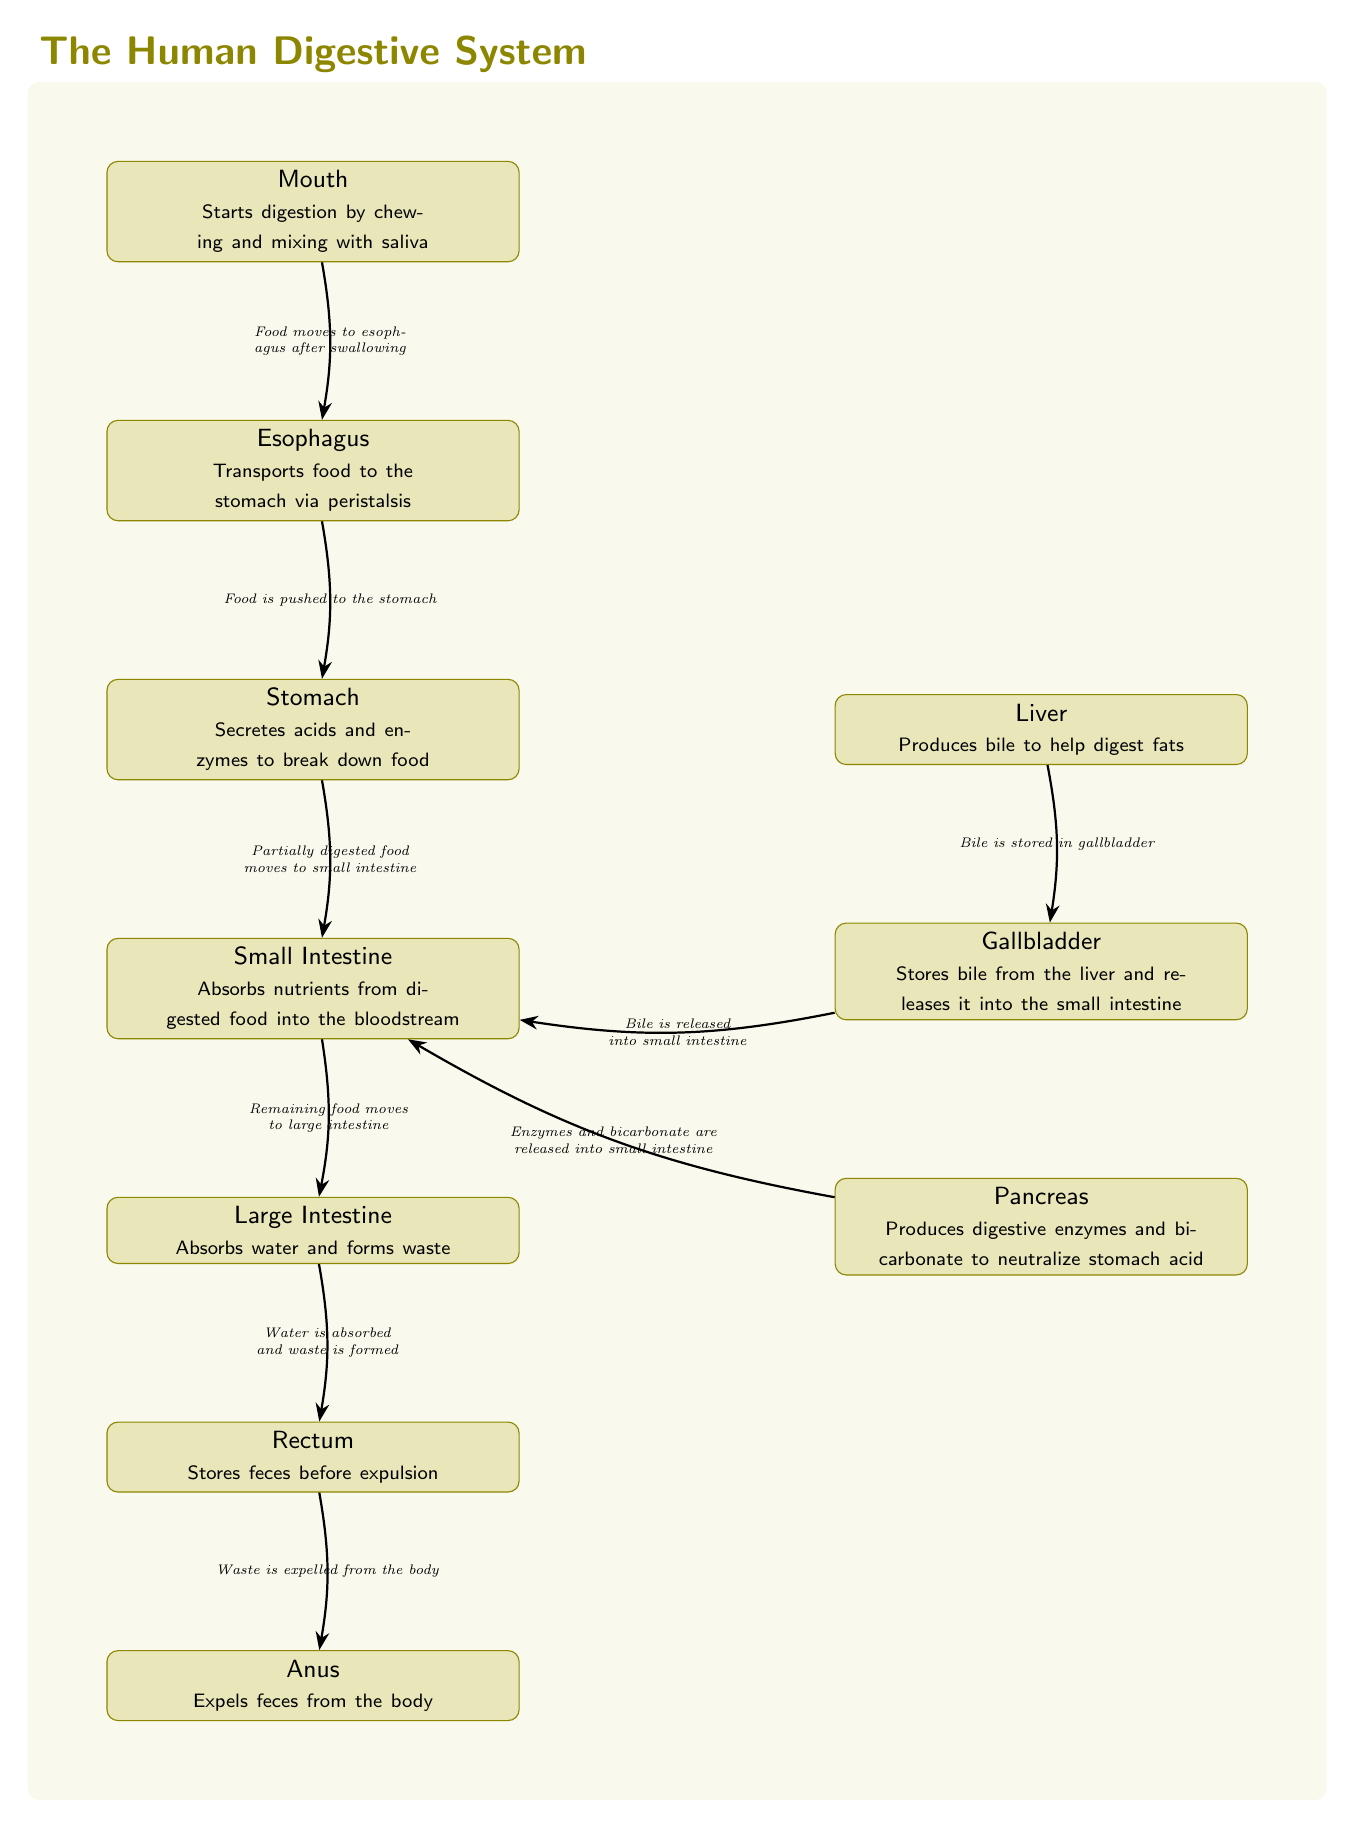What is the first organ in the digestive system? The flow of the diagram starts from the mouth, which is the first organ in the digestive system.
Answer: Mouth How many major organs are in the diagram? The diagram includes seven major organs in the digestive system, which can be counted as mouth, esophagus, stomach, small intestine, large intestine, rectum, and anus.
Answer: Seven What is secreted by the stomach? The diagram states that the stomach secretes acids and enzymes to break down food.
Answer: Acids and enzymes What is the function of the small intestine? The small intestine's function as indicated in the diagram is to absorb nutrients from digested food into the bloodstream.
Answer: Absorbs nutrients Which two organs are connected by the gallbladder? The gallbladder connects the liver and the small intestine according to the flow of the arrows in the diagram.
Answer: Liver and small intestine What is produced by the pancreas? The diagram indicates that the pancreas produces digestive enzymes and bicarbonate to neutralize stomach acid.
Answer: Digestive enzymes and bicarbonate What happens to water in the large intestine? The diagram shows that the large intestine absorbs water and forms waste, so the primary action regarding water is absorption.
Answer: Absorbs water What does the rectum do with feces? The diagram states that the rectum stores feces before expulsion, indicating its role in the final steps of digestion.
Answer: Stores feces What is the function of bile as produced by the liver? According to the diagram, bile's function is to help digest fats, as produced by the liver.
Answer: Helps digest fats 